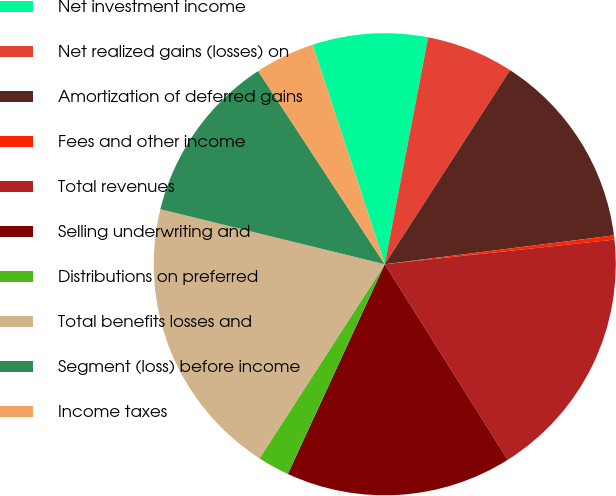<chart> <loc_0><loc_0><loc_500><loc_500><pie_chart><fcel>Net investment income<fcel>Net realized gains (losses) on<fcel>Amortization of deferred gains<fcel>Fees and other income<fcel>Total revenues<fcel>Selling underwriting and<fcel>Distributions on preferred<fcel>Total benefits losses and<fcel>Segment (loss) before income<fcel>Income taxes<nl><fcel>8.06%<fcel>6.12%<fcel>13.88%<fcel>0.29%<fcel>17.77%<fcel>15.82%<fcel>2.23%<fcel>19.71%<fcel>11.94%<fcel>4.18%<nl></chart> 